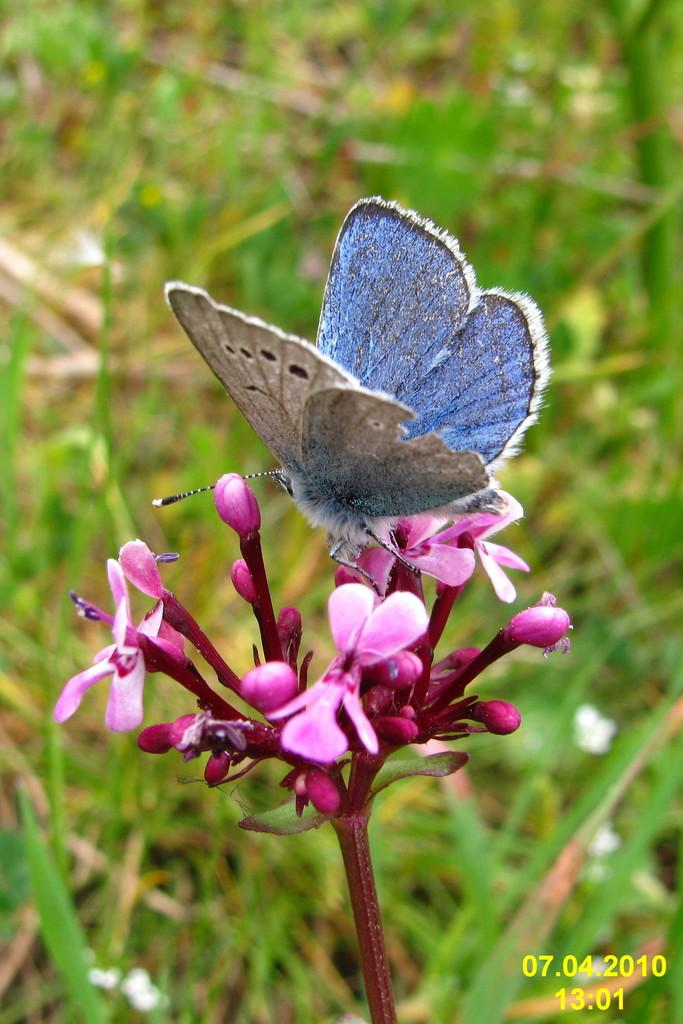What is the main subject of the image? The main subject of the image is a stem with pink colored flowers. Are there any other living creatures in the image? Yes, there is a butterfly in the image. What can be seen in the background of the image? There are many plants visible behind the stem in the image. What type of food is the butterfly eating in the image? There is no food visible in the image, and the butterfly is not shown eating anything. 